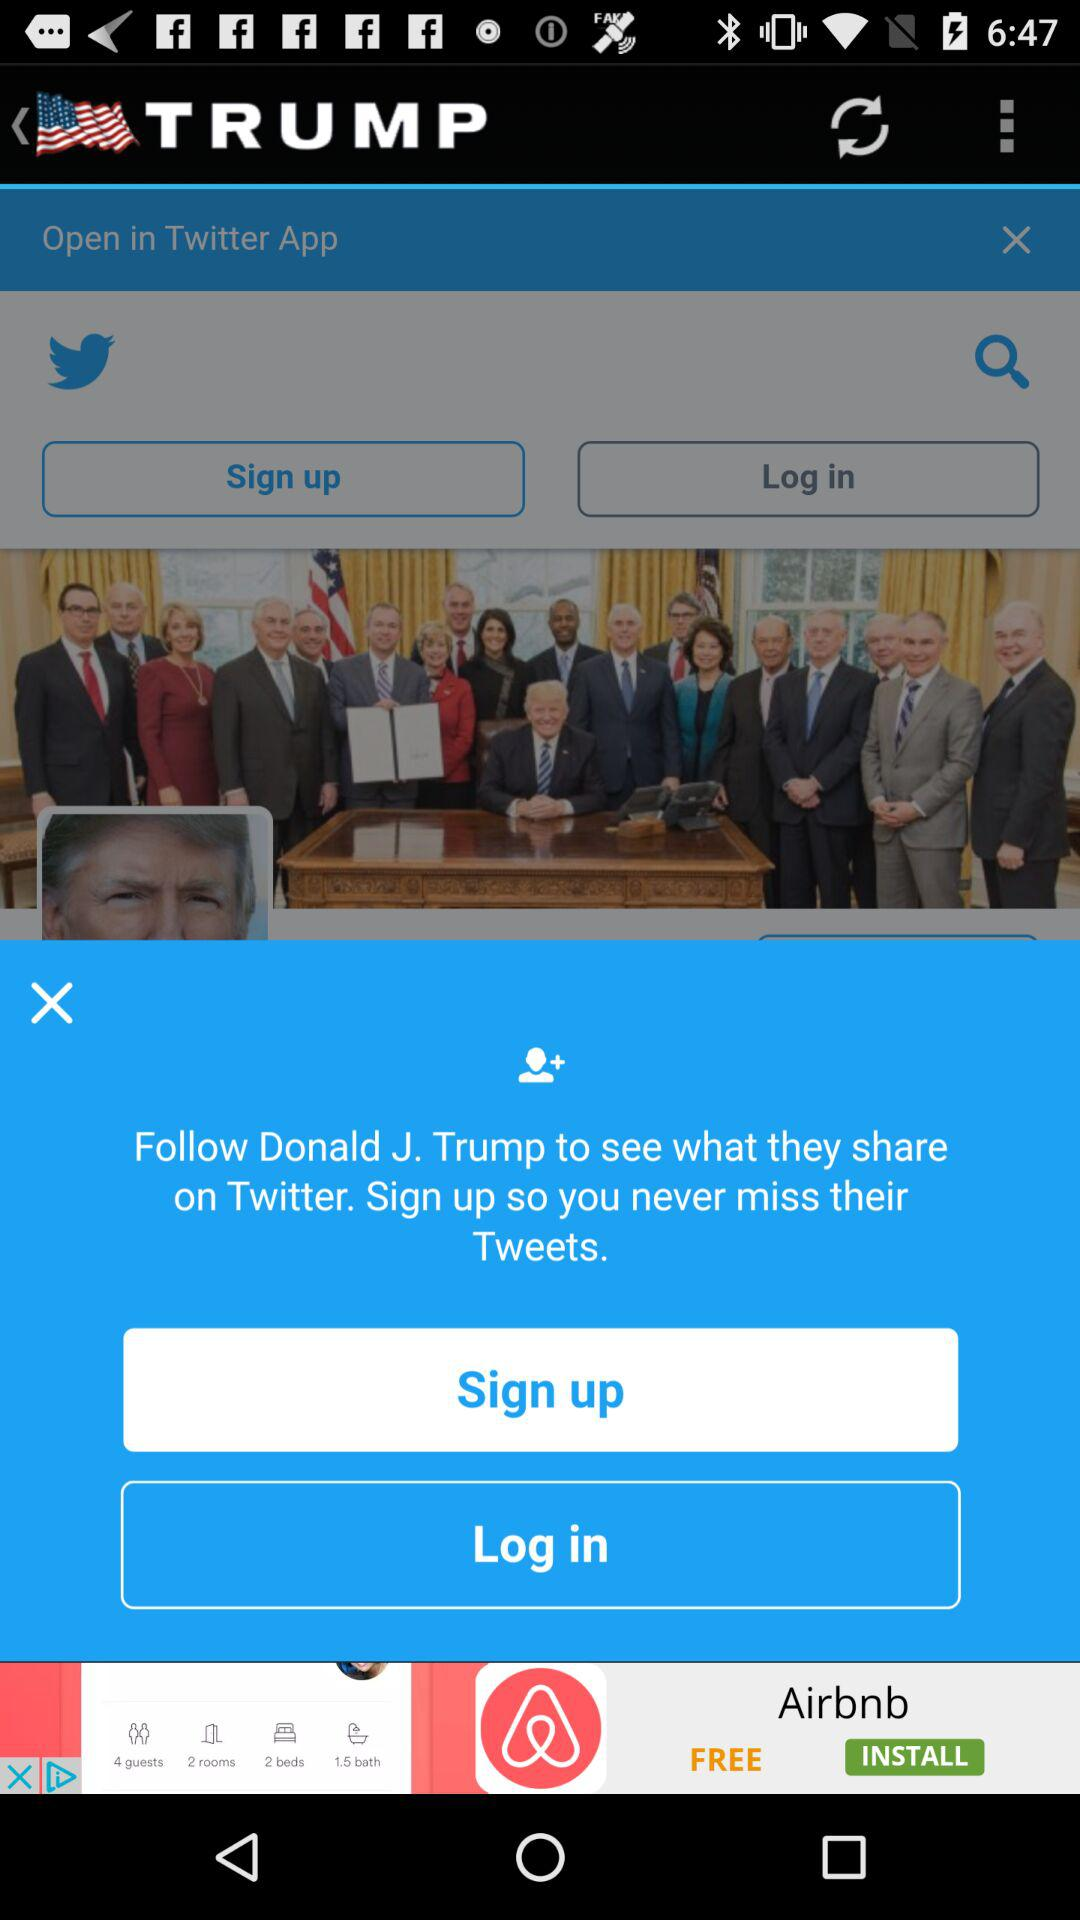What is the name of the application? The name of the application is "Twitter". 